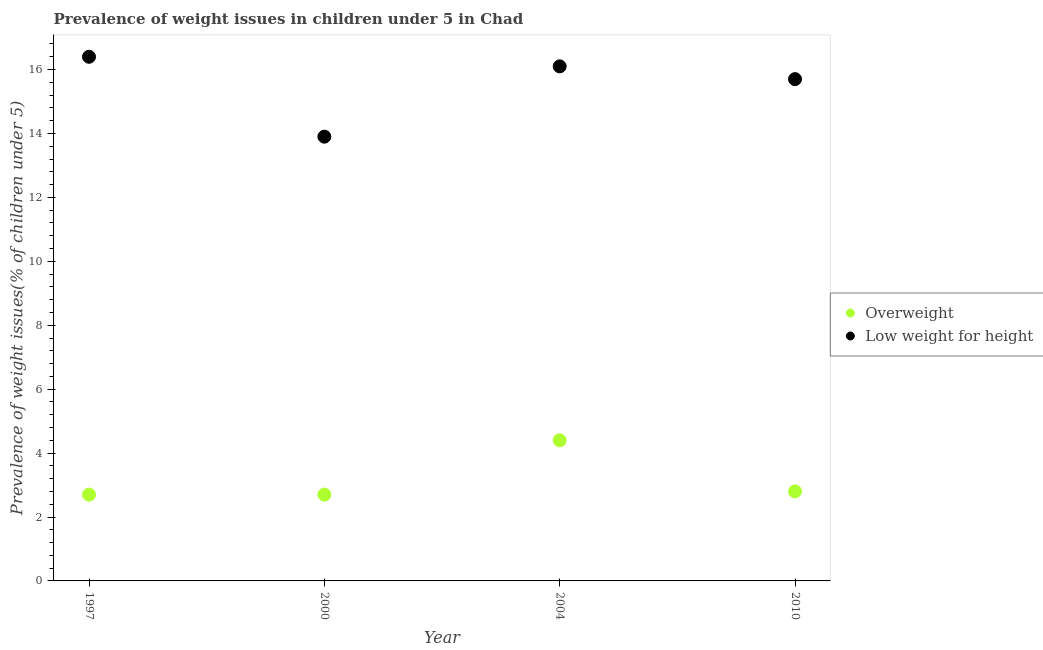How many different coloured dotlines are there?
Your response must be concise. 2. What is the percentage of underweight children in 1997?
Offer a terse response. 16.4. Across all years, what is the maximum percentage of overweight children?
Offer a terse response. 4.4. Across all years, what is the minimum percentage of underweight children?
Your response must be concise. 13.9. In which year was the percentage of overweight children maximum?
Your response must be concise. 2004. In which year was the percentage of overweight children minimum?
Provide a short and direct response. 1997. What is the total percentage of underweight children in the graph?
Make the answer very short. 62.1. What is the difference between the percentage of overweight children in 1997 and that in 2010?
Provide a succinct answer. -0.1. What is the difference between the percentage of underweight children in 2000 and the percentage of overweight children in 2004?
Your answer should be compact. 9.5. What is the average percentage of overweight children per year?
Provide a short and direct response. 3.15. In the year 1997, what is the difference between the percentage of underweight children and percentage of overweight children?
Provide a short and direct response. 13.7. In how many years, is the percentage of overweight children greater than 14.4 %?
Ensure brevity in your answer.  0. What is the ratio of the percentage of overweight children in 1997 to that in 2000?
Keep it short and to the point. 1. Is the percentage of overweight children in 2000 less than that in 2010?
Provide a succinct answer. Yes. Is the difference between the percentage of overweight children in 1997 and 2010 greater than the difference between the percentage of underweight children in 1997 and 2010?
Provide a short and direct response. No. What is the difference between the highest and the second highest percentage of underweight children?
Keep it short and to the point. 0.3. What is the difference between the highest and the lowest percentage of overweight children?
Provide a short and direct response. 1.7. In how many years, is the percentage of underweight children greater than the average percentage of underweight children taken over all years?
Offer a terse response. 3. Does the percentage of overweight children monotonically increase over the years?
Keep it short and to the point. No. Is the percentage of overweight children strictly less than the percentage of underweight children over the years?
Keep it short and to the point. Yes. How many dotlines are there?
Your answer should be very brief. 2. How many years are there in the graph?
Make the answer very short. 4. What is the difference between two consecutive major ticks on the Y-axis?
Your answer should be compact. 2. Where does the legend appear in the graph?
Your answer should be compact. Center right. How many legend labels are there?
Ensure brevity in your answer.  2. How are the legend labels stacked?
Make the answer very short. Vertical. What is the title of the graph?
Your answer should be compact. Prevalence of weight issues in children under 5 in Chad. What is the label or title of the X-axis?
Give a very brief answer. Year. What is the label or title of the Y-axis?
Your answer should be very brief. Prevalence of weight issues(% of children under 5). What is the Prevalence of weight issues(% of children under 5) of Overweight in 1997?
Ensure brevity in your answer.  2.7. What is the Prevalence of weight issues(% of children under 5) of Low weight for height in 1997?
Offer a very short reply. 16.4. What is the Prevalence of weight issues(% of children under 5) in Overweight in 2000?
Keep it short and to the point. 2.7. What is the Prevalence of weight issues(% of children under 5) in Low weight for height in 2000?
Your answer should be very brief. 13.9. What is the Prevalence of weight issues(% of children under 5) of Overweight in 2004?
Keep it short and to the point. 4.4. What is the Prevalence of weight issues(% of children under 5) in Low weight for height in 2004?
Your response must be concise. 16.1. What is the Prevalence of weight issues(% of children under 5) in Overweight in 2010?
Provide a short and direct response. 2.8. What is the Prevalence of weight issues(% of children under 5) of Low weight for height in 2010?
Offer a terse response. 15.7. Across all years, what is the maximum Prevalence of weight issues(% of children under 5) in Overweight?
Provide a short and direct response. 4.4. Across all years, what is the maximum Prevalence of weight issues(% of children under 5) of Low weight for height?
Ensure brevity in your answer.  16.4. Across all years, what is the minimum Prevalence of weight issues(% of children under 5) in Overweight?
Offer a very short reply. 2.7. Across all years, what is the minimum Prevalence of weight issues(% of children under 5) in Low weight for height?
Offer a very short reply. 13.9. What is the total Prevalence of weight issues(% of children under 5) of Overweight in the graph?
Your answer should be very brief. 12.6. What is the total Prevalence of weight issues(% of children under 5) in Low weight for height in the graph?
Your answer should be very brief. 62.1. What is the difference between the Prevalence of weight issues(% of children under 5) of Overweight in 1997 and that in 2000?
Offer a terse response. 0. What is the difference between the Prevalence of weight issues(% of children under 5) of Low weight for height in 1997 and that in 2000?
Give a very brief answer. 2.5. What is the difference between the Prevalence of weight issues(% of children under 5) of Low weight for height in 1997 and that in 2004?
Keep it short and to the point. 0.3. What is the difference between the Prevalence of weight issues(% of children under 5) in Low weight for height in 1997 and that in 2010?
Your response must be concise. 0.7. What is the difference between the Prevalence of weight issues(% of children under 5) in Overweight in 2000 and that in 2004?
Ensure brevity in your answer.  -1.7. What is the difference between the Prevalence of weight issues(% of children under 5) of Low weight for height in 2000 and that in 2004?
Keep it short and to the point. -2.2. What is the difference between the Prevalence of weight issues(% of children under 5) in Low weight for height in 2004 and that in 2010?
Offer a very short reply. 0.4. What is the difference between the Prevalence of weight issues(% of children under 5) of Overweight in 1997 and the Prevalence of weight issues(% of children under 5) of Low weight for height in 2000?
Offer a very short reply. -11.2. What is the difference between the Prevalence of weight issues(% of children under 5) of Overweight in 1997 and the Prevalence of weight issues(% of children under 5) of Low weight for height in 2004?
Give a very brief answer. -13.4. What is the difference between the Prevalence of weight issues(% of children under 5) in Overweight in 1997 and the Prevalence of weight issues(% of children under 5) in Low weight for height in 2010?
Your answer should be compact. -13. What is the difference between the Prevalence of weight issues(% of children under 5) of Overweight in 2000 and the Prevalence of weight issues(% of children under 5) of Low weight for height in 2010?
Give a very brief answer. -13. What is the difference between the Prevalence of weight issues(% of children under 5) in Overweight in 2004 and the Prevalence of weight issues(% of children under 5) in Low weight for height in 2010?
Provide a succinct answer. -11.3. What is the average Prevalence of weight issues(% of children under 5) of Overweight per year?
Your response must be concise. 3.15. What is the average Prevalence of weight issues(% of children under 5) in Low weight for height per year?
Your response must be concise. 15.53. In the year 1997, what is the difference between the Prevalence of weight issues(% of children under 5) in Overweight and Prevalence of weight issues(% of children under 5) in Low weight for height?
Provide a succinct answer. -13.7. In the year 2004, what is the difference between the Prevalence of weight issues(% of children under 5) in Overweight and Prevalence of weight issues(% of children under 5) in Low weight for height?
Give a very brief answer. -11.7. What is the ratio of the Prevalence of weight issues(% of children under 5) of Low weight for height in 1997 to that in 2000?
Ensure brevity in your answer.  1.18. What is the ratio of the Prevalence of weight issues(% of children under 5) in Overweight in 1997 to that in 2004?
Your answer should be compact. 0.61. What is the ratio of the Prevalence of weight issues(% of children under 5) of Low weight for height in 1997 to that in 2004?
Give a very brief answer. 1.02. What is the ratio of the Prevalence of weight issues(% of children under 5) in Overweight in 1997 to that in 2010?
Give a very brief answer. 0.96. What is the ratio of the Prevalence of weight issues(% of children under 5) in Low weight for height in 1997 to that in 2010?
Your response must be concise. 1.04. What is the ratio of the Prevalence of weight issues(% of children under 5) of Overweight in 2000 to that in 2004?
Make the answer very short. 0.61. What is the ratio of the Prevalence of weight issues(% of children under 5) of Low weight for height in 2000 to that in 2004?
Your answer should be compact. 0.86. What is the ratio of the Prevalence of weight issues(% of children under 5) of Low weight for height in 2000 to that in 2010?
Offer a very short reply. 0.89. What is the ratio of the Prevalence of weight issues(% of children under 5) of Overweight in 2004 to that in 2010?
Offer a very short reply. 1.57. What is the ratio of the Prevalence of weight issues(% of children under 5) in Low weight for height in 2004 to that in 2010?
Offer a terse response. 1.03. What is the difference between the highest and the second highest Prevalence of weight issues(% of children under 5) of Overweight?
Provide a short and direct response. 1.6. What is the difference between the highest and the lowest Prevalence of weight issues(% of children under 5) in Overweight?
Offer a terse response. 1.7. 